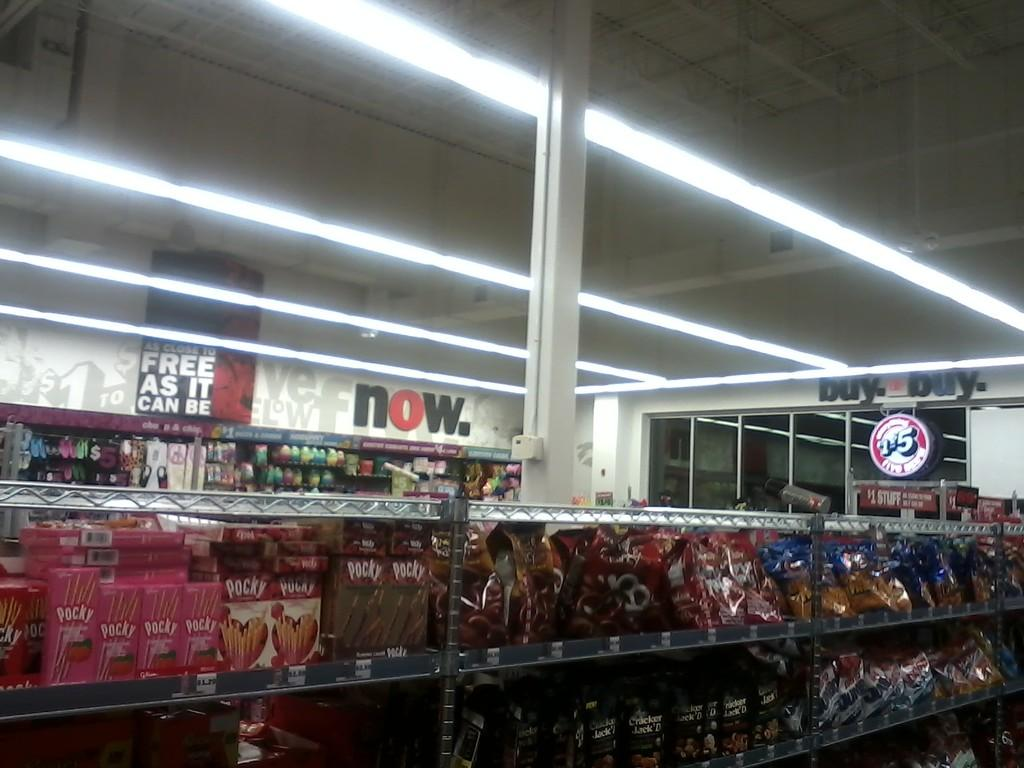Provide a one-sentence caption for the provided image. A store has a sign that says Buy Buy on the wall. 